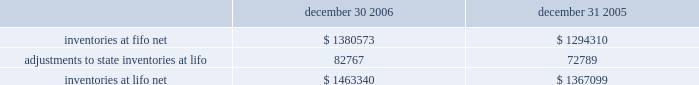Advance auto parts , inc .
And subsidiaries notes to consolidated financial statements 2013 ( continued ) december 30 , 2006 , december 31 , 2005 and january 1 , 2005 ( in thousands , except per share data ) 8 .
Inventories , net inventories are stated at the lower of cost or market , cost being determined using the last-in , first-out ( "lifo" ) method for approximately 93% ( 93 % ) of inventories at both december 30 , 2006 and december 31 , 2005 .
Under the lifo method , the company 2019s cost of sales reflects the costs of the most currently purchased inventories while the inventory carrying balance represents the costs relating to prices paid in prior years .
The company 2019s costs to acquire inventory have been generally decreasing in recent years as a result of its significant growth .
Accordingly , the cost to replace inventory is less than the lifo balances carried for similar product .
As a result of the lifo method and the ability to obtain lower product costs , the company recorded a reduction to cost of sales of $ 9978 for fiscal year ended 2006 , an increase in cost of sales of $ 526 for fiscal year ended 2005 and a reduction to cost of sales of $ 11212 for fiscal year ended 2004 .
The remaining inventories are comprised of product cores , which consist of the non-consumable portion of certain parts and batteries and are valued under the first-in , first-out ( "fifo" ) method .
Core values are included as part of our merchandise costs and are either passed on to the customer or returned to the vendor .
Additionally , these products are not subject to the frequent cost changes like our other merchandise inventory , thus , there is no material difference from applying either the lifo or fifo valuation methods .
The company capitalizes certain purchasing and warehousing costs into inventory .
Purchasing and warehousing costs included in inventory , at fifo , at december 30 , 2006 and december 31 , 2005 , were $ 95576 and $ 92833 , respectively .
Inventories consist of the following : december 30 , december 31 , 2006 2005 .
Replacement cost approximated fifo cost at december 30 , 2006 and december 31 , 2005 .
Inventory quantities are tracked through a perpetual inventory system .
The company uses a cycle counting program in all distribution centers , parts delivered quickly warehouses , or pdqs , local area warehouses , or laws , and retail stores to ensure the accuracy of the perpetual inventory quantities of both merchandise and core inventory .
The company establishes reserves for estimated shrink based on historical accuracy and effectiveness of the cycle counting program .
The company also establishes reserves for potentially excess and obsolete inventories based on current inventory levels and the historical analysis of product sales and current market conditions .
The nature of the company 2019s inventory is such that the risk of obsolescence is minimal and excess inventory has historically been returned to the company 2019s vendors for credit .
The company provides reserves when less than full credit is expected from a vendor or when liquidating product will result in retail prices below recorded costs .
The company 2019s reserves against inventory for these matters were $ 31376 and $ 22825 at december 30 , 2006 and december 31 , 2005 , respectively .
Property and equipment : property and equipment are stated at cost , less accumulated depreciation .
Expenditures for maintenance and repairs are charged directly to expense when incurred ; major improvements are capitalized .
When items are sold or retired , the related cost and accumulated depreciation are removed from the accounts , with any gain or loss reflected in the consolidated statements of operations .
Depreciation of land improvements , buildings , furniture , fixtures and equipment , and vehicles is provided over the estimated useful lives , which range from 2 to 40 years , of the respective assets using the straight-line method. .
What is the percentage increase in inventories due to the adoption of lifo in 2005? 
Computations: (72789 / 1294310)
Answer: 0.05624. Advance auto parts , inc .
And subsidiaries notes to consolidated financial statements 2013 ( continued ) december 30 , 2006 , december 31 , 2005 and january 1 , 2005 ( in thousands , except per share data ) 8 .
Inventories , net inventories are stated at the lower of cost or market , cost being determined using the last-in , first-out ( "lifo" ) method for approximately 93% ( 93 % ) of inventories at both december 30 , 2006 and december 31 , 2005 .
Under the lifo method , the company 2019s cost of sales reflects the costs of the most currently purchased inventories while the inventory carrying balance represents the costs relating to prices paid in prior years .
The company 2019s costs to acquire inventory have been generally decreasing in recent years as a result of its significant growth .
Accordingly , the cost to replace inventory is less than the lifo balances carried for similar product .
As a result of the lifo method and the ability to obtain lower product costs , the company recorded a reduction to cost of sales of $ 9978 for fiscal year ended 2006 , an increase in cost of sales of $ 526 for fiscal year ended 2005 and a reduction to cost of sales of $ 11212 for fiscal year ended 2004 .
The remaining inventories are comprised of product cores , which consist of the non-consumable portion of certain parts and batteries and are valued under the first-in , first-out ( "fifo" ) method .
Core values are included as part of our merchandise costs and are either passed on to the customer or returned to the vendor .
Additionally , these products are not subject to the frequent cost changes like our other merchandise inventory , thus , there is no material difference from applying either the lifo or fifo valuation methods .
The company capitalizes certain purchasing and warehousing costs into inventory .
Purchasing and warehousing costs included in inventory , at fifo , at december 30 , 2006 and december 31 , 2005 , were $ 95576 and $ 92833 , respectively .
Inventories consist of the following : december 30 , december 31 , 2006 2005 .
Replacement cost approximated fifo cost at december 30 , 2006 and december 31 , 2005 .
Inventory quantities are tracked through a perpetual inventory system .
The company uses a cycle counting program in all distribution centers , parts delivered quickly warehouses , or pdqs , local area warehouses , or laws , and retail stores to ensure the accuracy of the perpetual inventory quantities of both merchandise and core inventory .
The company establishes reserves for estimated shrink based on historical accuracy and effectiveness of the cycle counting program .
The company also establishes reserves for potentially excess and obsolete inventories based on current inventory levels and the historical analysis of product sales and current market conditions .
The nature of the company 2019s inventory is such that the risk of obsolescence is minimal and excess inventory has historically been returned to the company 2019s vendors for credit .
The company provides reserves when less than full credit is expected from a vendor or when liquidating product will result in retail prices below recorded costs .
The company 2019s reserves against inventory for these matters were $ 31376 and $ 22825 at december 30 , 2006 and december 31 , 2005 , respectively .
Property and equipment : property and equipment are stated at cost , less accumulated depreciation .
Expenditures for maintenance and repairs are charged directly to expense when incurred ; major improvements are capitalized .
When items are sold or retired , the related cost and accumulated depreciation are removed from the accounts , with any gain or loss reflected in the consolidated statements of operations .
Depreciation of land improvements , buildings , furniture , fixtures and equipment , and vehicles is provided over the estimated useful lives , which range from 2 to 40 years , of the respective assets using the straight-line method. .
What was the total decrease of cost of sales due to the adoption of the lifo method? 
Rationale: to find the total decrease of cost of sales one must add the decreases of cost of sales and then subtract the increase in cost of sales to get the total decrease of cost of sales .
Computations: ((9978 + 11212) - 526)
Answer: 20664.0. Advance auto parts , inc .
And subsidiaries notes to consolidated financial statements 2013 ( continued ) december 30 , 2006 , december 31 , 2005 and january 1 , 2005 ( in thousands , except per share data ) 8 .
Inventories , net inventories are stated at the lower of cost or market , cost being determined using the last-in , first-out ( "lifo" ) method for approximately 93% ( 93 % ) of inventories at both december 30 , 2006 and december 31 , 2005 .
Under the lifo method , the company 2019s cost of sales reflects the costs of the most currently purchased inventories while the inventory carrying balance represents the costs relating to prices paid in prior years .
The company 2019s costs to acquire inventory have been generally decreasing in recent years as a result of its significant growth .
Accordingly , the cost to replace inventory is less than the lifo balances carried for similar product .
As a result of the lifo method and the ability to obtain lower product costs , the company recorded a reduction to cost of sales of $ 9978 for fiscal year ended 2006 , an increase in cost of sales of $ 526 for fiscal year ended 2005 and a reduction to cost of sales of $ 11212 for fiscal year ended 2004 .
The remaining inventories are comprised of product cores , which consist of the non-consumable portion of certain parts and batteries and are valued under the first-in , first-out ( "fifo" ) method .
Core values are included as part of our merchandise costs and are either passed on to the customer or returned to the vendor .
Additionally , these products are not subject to the frequent cost changes like our other merchandise inventory , thus , there is no material difference from applying either the lifo or fifo valuation methods .
The company capitalizes certain purchasing and warehousing costs into inventory .
Purchasing and warehousing costs included in inventory , at fifo , at december 30 , 2006 and december 31 , 2005 , were $ 95576 and $ 92833 , respectively .
Inventories consist of the following : december 30 , december 31 , 2006 2005 .
Replacement cost approximated fifo cost at december 30 , 2006 and december 31 , 2005 .
Inventory quantities are tracked through a perpetual inventory system .
The company uses a cycle counting program in all distribution centers , parts delivered quickly warehouses , or pdqs , local area warehouses , or laws , and retail stores to ensure the accuracy of the perpetual inventory quantities of both merchandise and core inventory .
The company establishes reserves for estimated shrink based on historical accuracy and effectiveness of the cycle counting program .
The company also establishes reserves for potentially excess and obsolete inventories based on current inventory levels and the historical analysis of product sales and current market conditions .
The nature of the company 2019s inventory is such that the risk of obsolescence is minimal and excess inventory has historically been returned to the company 2019s vendors for credit .
The company provides reserves when less than full credit is expected from a vendor or when liquidating product will result in retail prices below recorded costs .
The company 2019s reserves against inventory for these matters were $ 31376 and $ 22825 at december 30 , 2006 and december 31 , 2005 , respectively .
Property and equipment : property and equipment are stated at cost , less accumulated depreciation .
Expenditures for maintenance and repairs are charged directly to expense when incurred ; major improvements are capitalized .
When items are sold or retired , the related cost and accumulated depreciation are removed from the accounts , with any gain or loss reflected in the consolidated statements of operations .
Depreciation of land improvements , buildings , furniture , fixtures and equipment , and vehicles is provided over the estimated useful lives , which range from 2 to 40 years , of the respective assets using the straight-line method. .
What was the percentage change in reserves against inventory from 2005 to 2006? 
Rationale: to find the percentage change in reserves against inventory from 2005 to 2006 one must subtract the 2006 number from the 2005 and then take the answer and divide it by the reserves against inventory for 2005 .
Computations: ((31376 - 22825) / 22825)
Answer: 0.37463. 